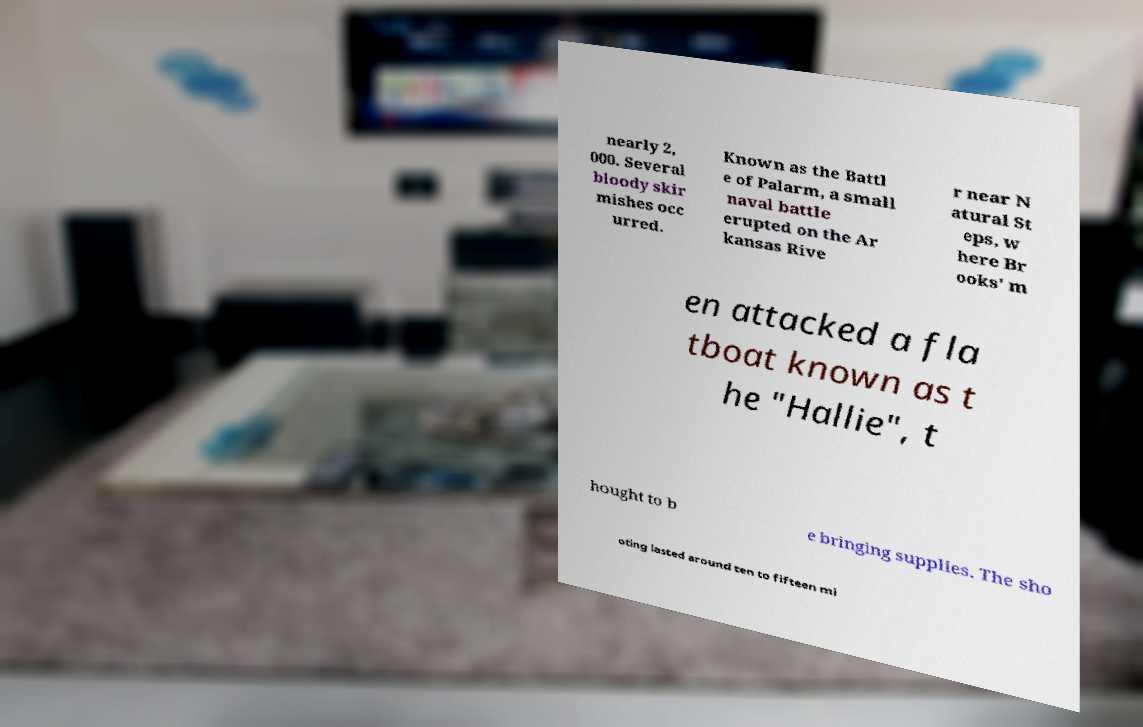I need the written content from this picture converted into text. Can you do that? nearly 2, 000. Several bloody skir mishes occ urred. Known as the Battl e of Palarm, a small naval battle erupted on the Ar kansas Rive r near N atural St eps, w here Br ooks' m en attacked a fla tboat known as t he "Hallie", t hought to b e bringing supplies. The sho oting lasted around ten to fifteen mi 